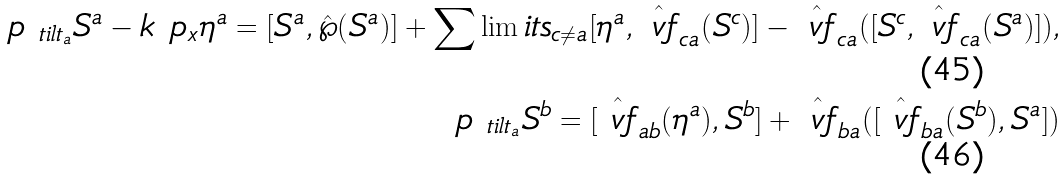Convert formula to latex. <formula><loc_0><loc_0><loc_500><loc_500>\ p _ { \ t i l t _ { a } } S ^ { a } - k \ p _ { x } \eta ^ { a } = [ S ^ { a } , \hat { \wp } ( S ^ { a } ) ] + \sum \lim i t s _ { c \neq a } [ \eta ^ { a } , \hat { \ v f } _ { c a } ( S ^ { c } ) ] - \hat { \ v f } _ { c a } ( [ S ^ { c } , \hat { \ v f } _ { c a } ( S ^ { a } ) ] ) , \\ \ p _ { \ t i l t _ { a } } S ^ { b } = [ \hat { \ v f } _ { a b } ( \eta ^ { a } ) , S ^ { b } ] + \hat { \ v f } _ { b a } ( [ \hat { \ v f } _ { b a } ( S ^ { b } ) , S ^ { a } ] )</formula> 